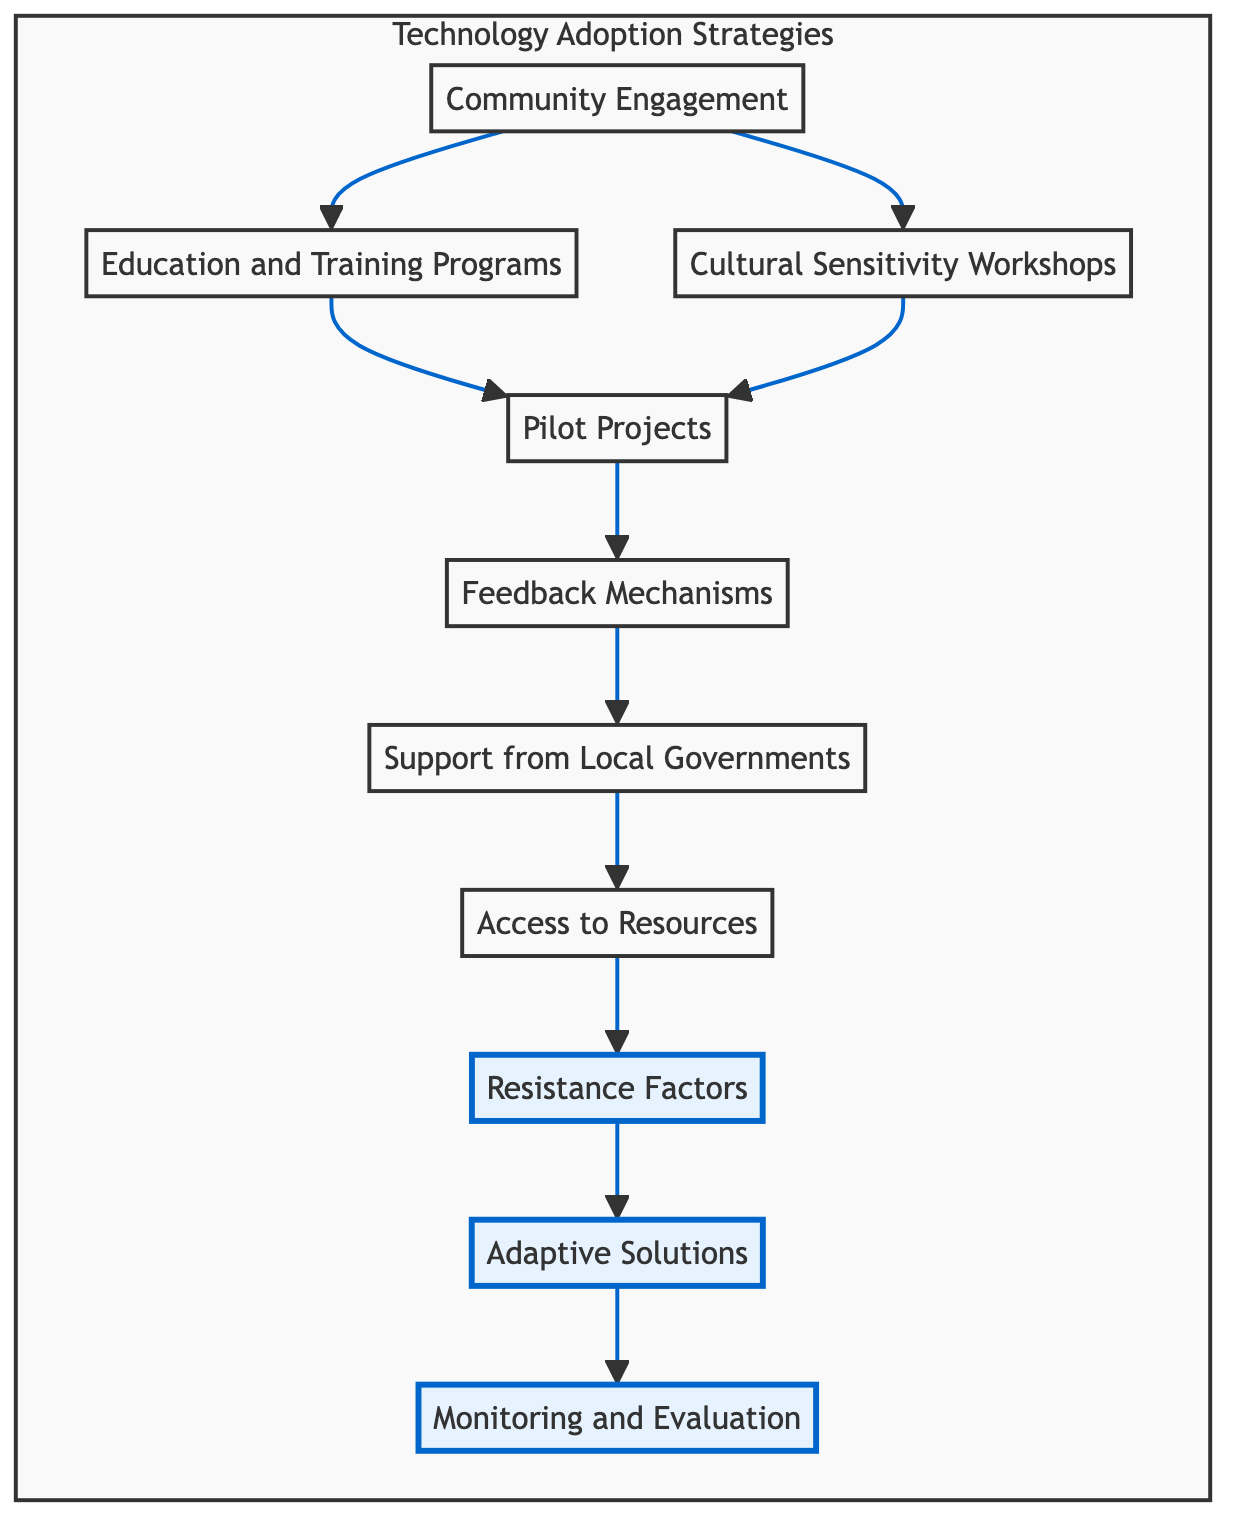What is the first step in the technology adoption strategies? According to the diagram, the first step is "Community Engagement," which is a key starting point for involving local leaders and community members in discussions about technology integration.
Answer: Community Engagement How many nodes are presented in the diagram? The diagram has ten nodes, each representing an aspect of the technology adoption process in villages. They include various strategies and resistance factors.
Answer: Ten What connects "Community Engagement" to "Education and Training Programs"? In the diagram, "Community Engagement" directly connects to "Education and Training Programs," indicating that engaging the community is essential for educating them on new technologies.
Answer: Education and Training Programs Which node follows "Pilot Projects" in the flow? The flow from "Pilot Projects" proceeds to "Feedback Mechanisms," emphasizing the need to gather input from villagers after small-scale initiatives have been launched.
Answer: Feedback Mechanisms What type of workshops does the diagram suggest for addressing cultural issues? The diagram indicates "Cultural Sensitivity Workshops" to be held, aimed at addressing how technology can complement local customs without erasing them.
Answer: Cultural Sensitivity Workshops What is the last step in the flow chart? The last step in the flow chart is "Monitoring and Evaluation," highlighting the importance of regularly assessing the impact of technologies on local customs and adjusting strategies accordingly.
Answer: Monitoring and Evaluation What relationships exist between "Resistance Factors" and "Adaptive Solutions"? "Resistance Factors" leads to "Adaptive Solutions," indicating that recognizing resistance can produce custom technology solutions that better fit local practices.
Answer: Adaptive Solutions Identify a node that includes government involvement. The node "Support from Local Governments" suggests the importance of cooperation with local government bodies for trust and legitimacy in technology adoption.
Answer: Support from Local Governments What flow follows after "Access to Resources"? Following "Access to Resources," the flow moves to "Resistance Factors," meaning that ensuring technology access paves the way for addressing potential fears among the villagers.
Answer: Resistance Factors 